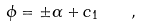<formula> <loc_0><loc_0><loc_500><loc_500>\phi = \pm \alpha + c _ { 1 } \quad ,</formula> 